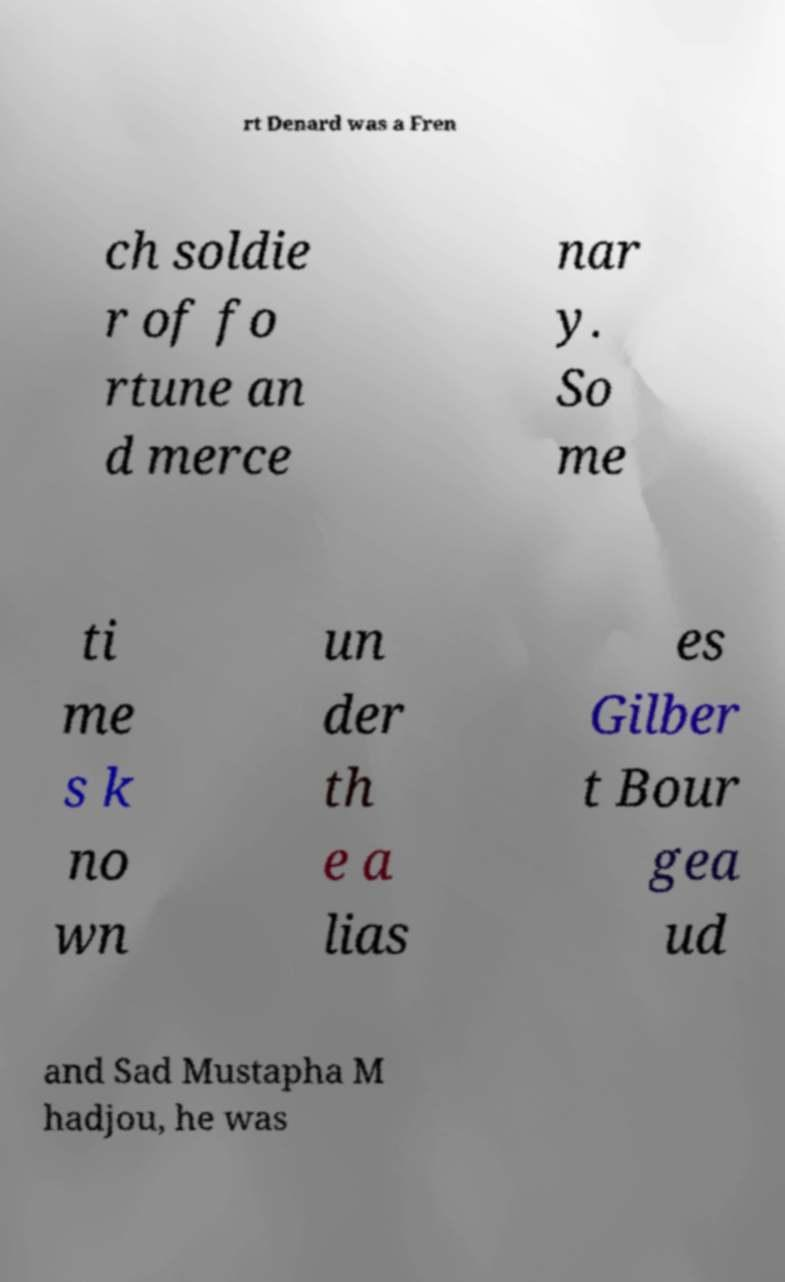There's text embedded in this image that I need extracted. Can you transcribe it verbatim? rt Denard was a Fren ch soldie r of fo rtune an d merce nar y. So me ti me s k no wn un der th e a lias es Gilber t Bour gea ud and Sad Mustapha M hadjou, he was 